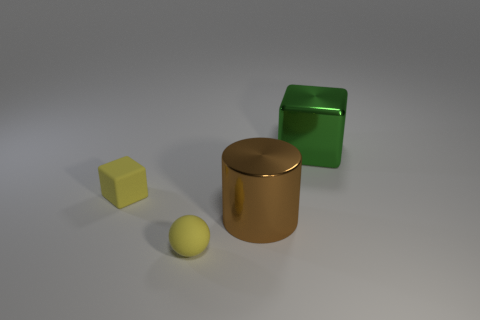Add 4 green metal blocks. How many objects exist? 8 Subtract all spheres. How many objects are left? 3 Add 2 green metallic blocks. How many green metallic blocks exist? 3 Subtract 0 blue blocks. How many objects are left? 4 Subtract all balls. Subtract all red shiny balls. How many objects are left? 3 Add 3 small blocks. How many small blocks are left? 4 